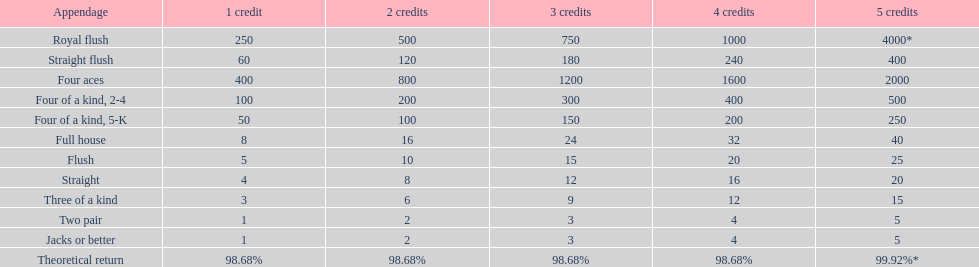Each four aces win is a multiple of what number? 400. 